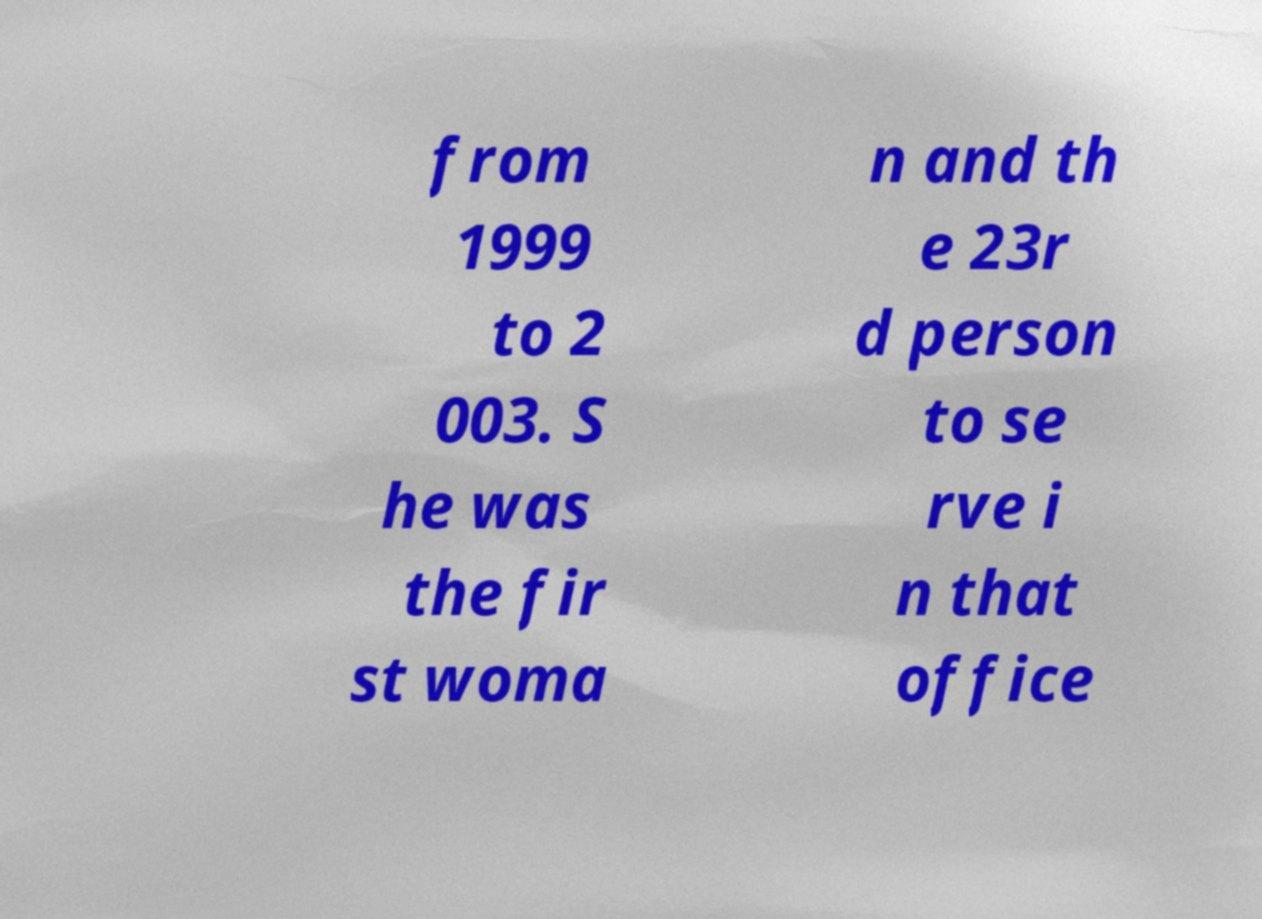What messages or text are displayed in this image? I need them in a readable, typed format. from 1999 to 2 003. S he was the fir st woma n and th e 23r d person to se rve i n that office 